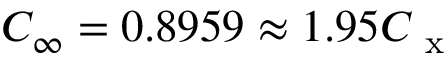<formula> <loc_0><loc_0><loc_500><loc_500>C _ { \infty } = 0 . 8 9 5 9 \approx 1 . 9 5 C _ { x }</formula> 